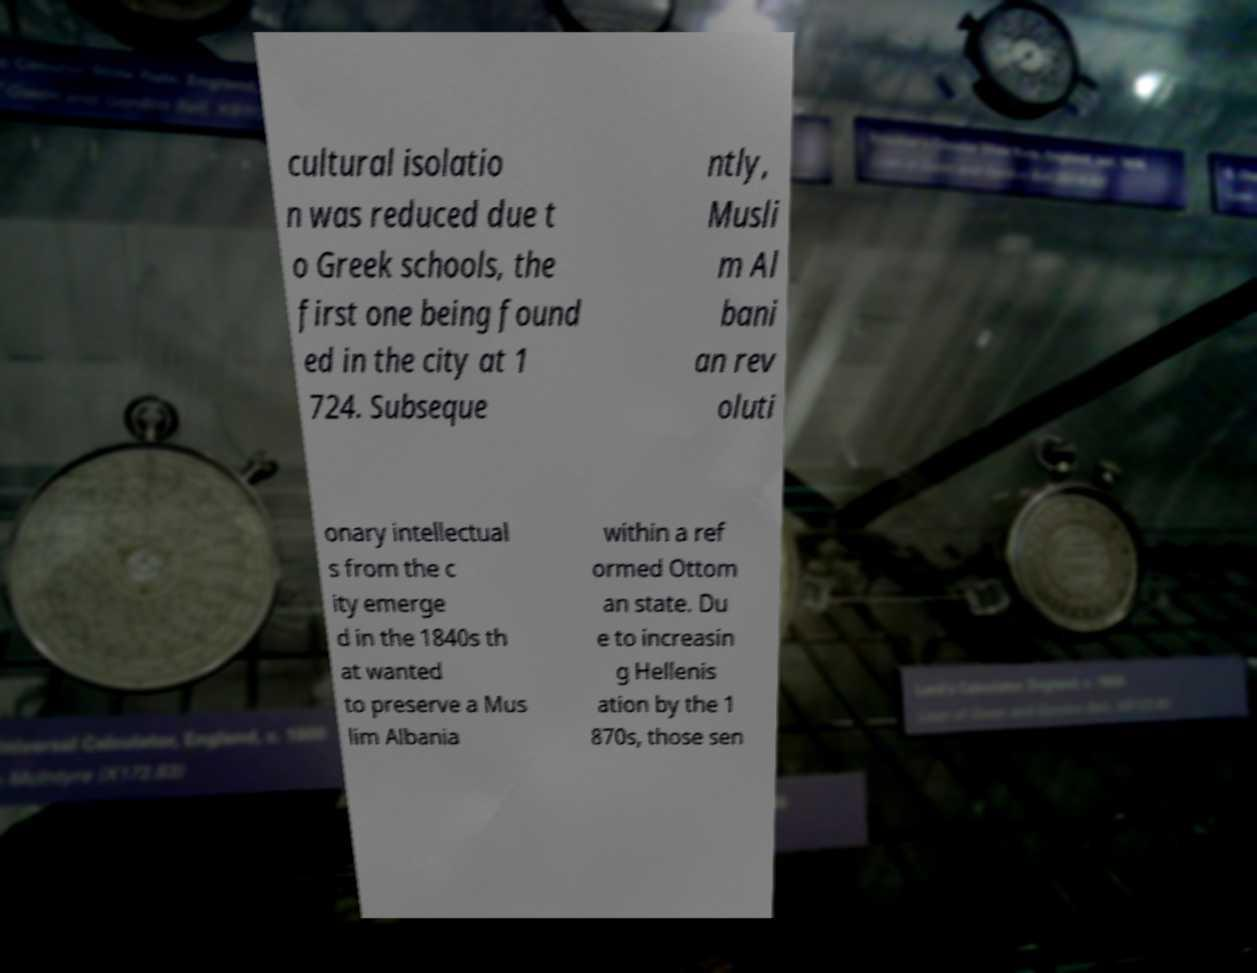Could you extract and type out the text from this image? cultural isolatio n was reduced due t o Greek schools, the first one being found ed in the city at 1 724. Subseque ntly, Musli m Al bani an rev oluti onary intellectual s from the c ity emerge d in the 1840s th at wanted to preserve a Mus lim Albania within a ref ormed Ottom an state. Du e to increasin g Hellenis ation by the 1 870s, those sen 